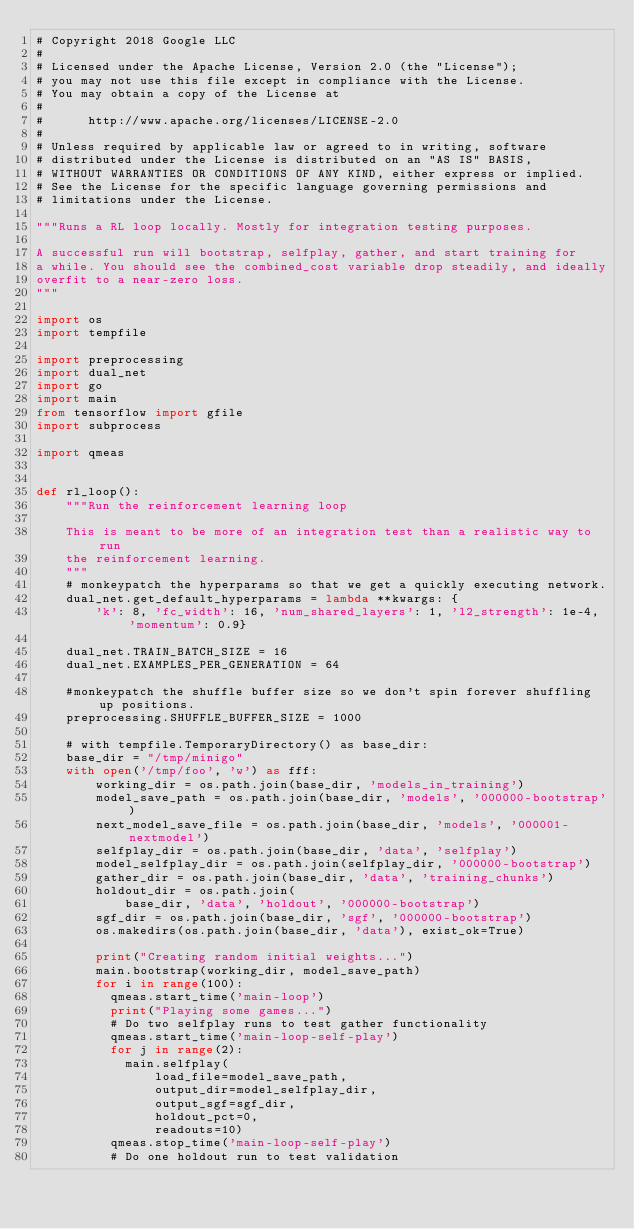<code> <loc_0><loc_0><loc_500><loc_500><_Python_># Copyright 2018 Google LLC
#
# Licensed under the Apache License, Version 2.0 (the "License");
# you may not use this file except in compliance with the License.
# You may obtain a copy of the License at
#
#      http://www.apache.org/licenses/LICENSE-2.0
#
# Unless required by applicable law or agreed to in writing, software
# distributed under the License is distributed on an "AS IS" BASIS,
# WITHOUT WARRANTIES OR CONDITIONS OF ANY KIND, either express or implied.
# See the License for the specific language governing permissions and
# limitations under the License.

"""Runs a RL loop locally. Mostly for integration testing purposes.

A successful run will bootstrap, selfplay, gather, and start training for
a while. You should see the combined_cost variable drop steadily, and ideally
overfit to a near-zero loss.
"""

import os
import tempfile

import preprocessing
import dual_net
import go
import main
from tensorflow import gfile
import subprocess

import qmeas


def rl_loop():
    """Run the reinforcement learning loop

    This is meant to be more of an integration test than a realistic way to run
    the reinforcement learning.
    """
    # monkeypatch the hyperparams so that we get a quickly executing network.
    dual_net.get_default_hyperparams = lambda **kwargs: {
        'k': 8, 'fc_width': 16, 'num_shared_layers': 1, 'l2_strength': 1e-4, 'momentum': 0.9}

    dual_net.TRAIN_BATCH_SIZE = 16
    dual_net.EXAMPLES_PER_GENERATION = 64

    #monkeypatch the shuffle buffer size so we don't spin forever shuffling up positions.
    preprocessing.SHUFFLE_BUFFER_SIZE = 1000

    # with tempfile.TemporaryDirectory() as base_dir:
    base_dir = "/tmp/minigo"
    with open('/tmp/foo', 'w') as fff:
        working_dir = os.path.join(base_dir, 'models_in_training')
        model_save_path = os.path.join(base_dir, 'models', '000000-bootstrap')
        next_model_save_file = os.path.join(base_dir, 'models', '000001-nextmodel')
        selfplay_dir = os.path.join(base_dir, 'data', 'selfplay')
        model_selfplay_dir = os.path.join(selfplay_dir, '000000-bootstrap')
        gather_dir = os.path.join(base_dir, 'data', 'training_chunks')
        holdout_dir = os.path.join(
            base_dir, 'data', 'holdout', '000000-bootstrap')
        sgf_dir = os.path.join(base_dir, 'sgf', '000000-bootstrap')
        os.makedirs(os.path.join(base_dir, 'data'), exist_ok=True)

        print("Creating random initial weights...")
        main.bootstrap(working_dir, model_save_path)
        for i in range(100):
          qmeas.start_time('main-loop')
          print("Playing some games...")
          # Do two selfplay runs to test gather functionality
          qmeas.start_time('main-loop-self-play')
          for j in range(2):
            main.selfplay(
                load_file=model_save_path,
                output_dir=model_selfplay_dir,
                output_sgf=sgf_dir,
                holdout_pct=0,
                readouts=10)
          qmeas.stop_time('main-loop-self-play')
          # Do one holdout run to test validation</code> 